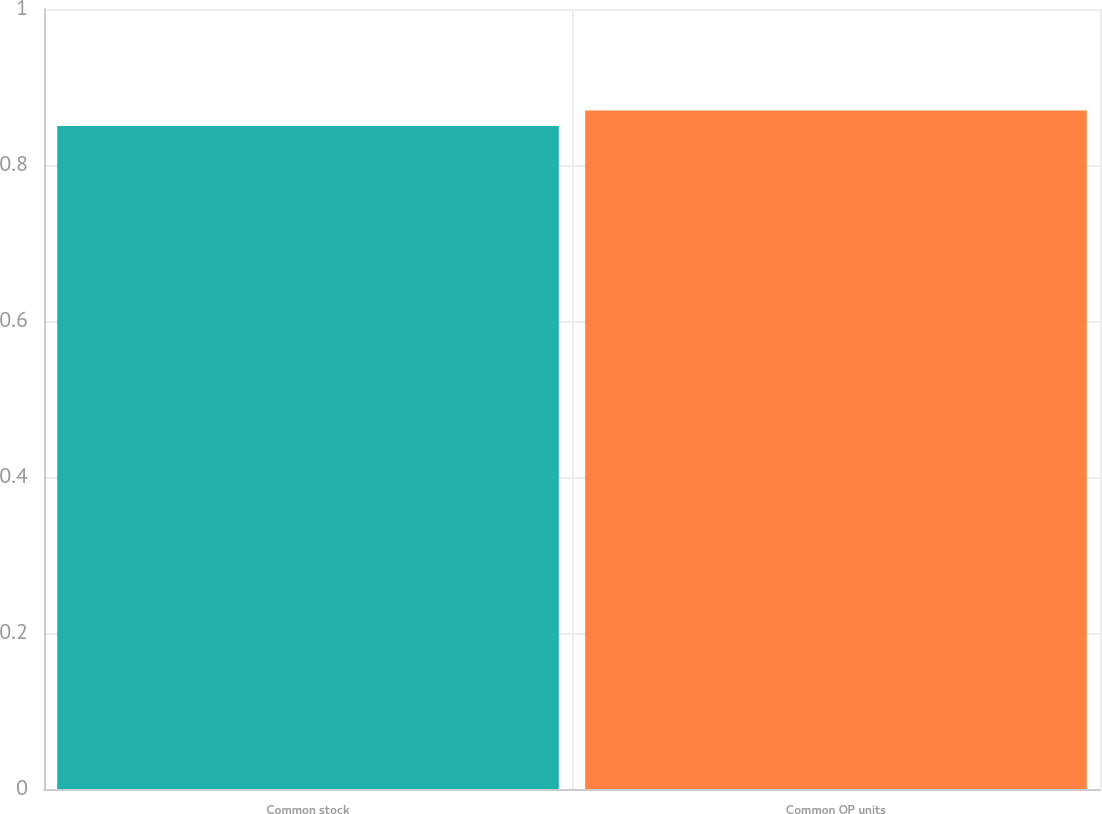<chart> <loc_0><loc_0><loc_500><loc_500><bar_chart><fcel>Common stock<fcel>Common OP units<nl><fcel>0.85<fcel>0.87<nl></chart> 